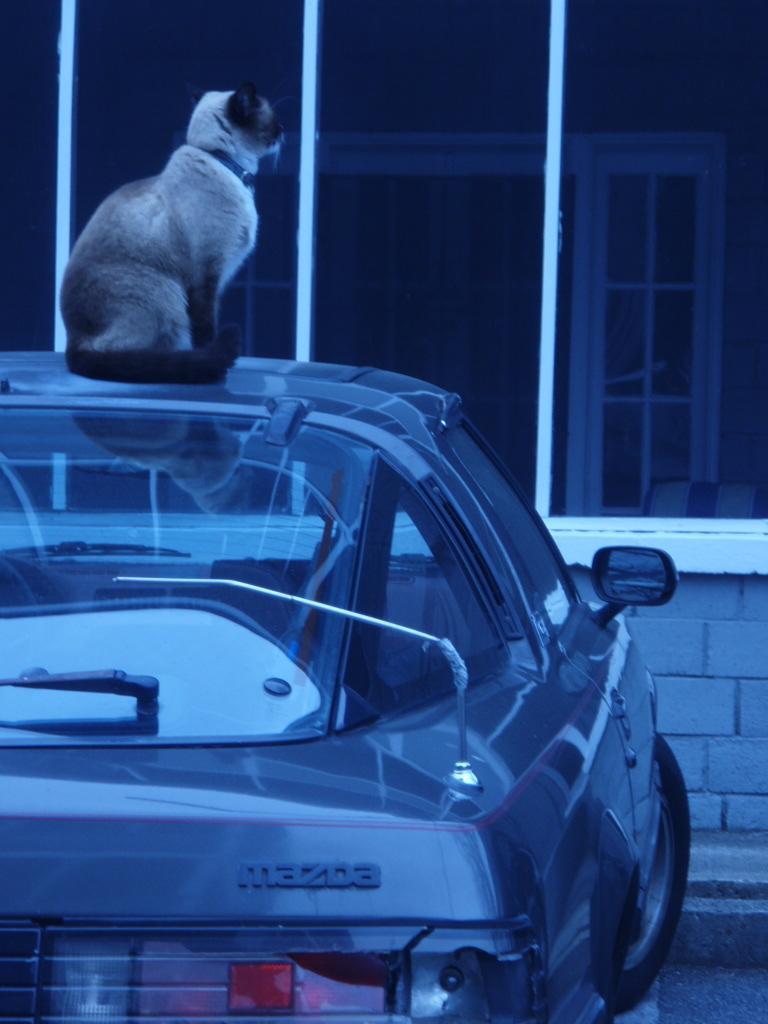In one or two sentences, can you explain what this image depicts? In this image there is a car truncated towards the right of the image, there is a cat on the car, there are windows truncated towards the top of the image, there is a wall truncated towards the right of the image, there is a road truncated towards the right of the image. 